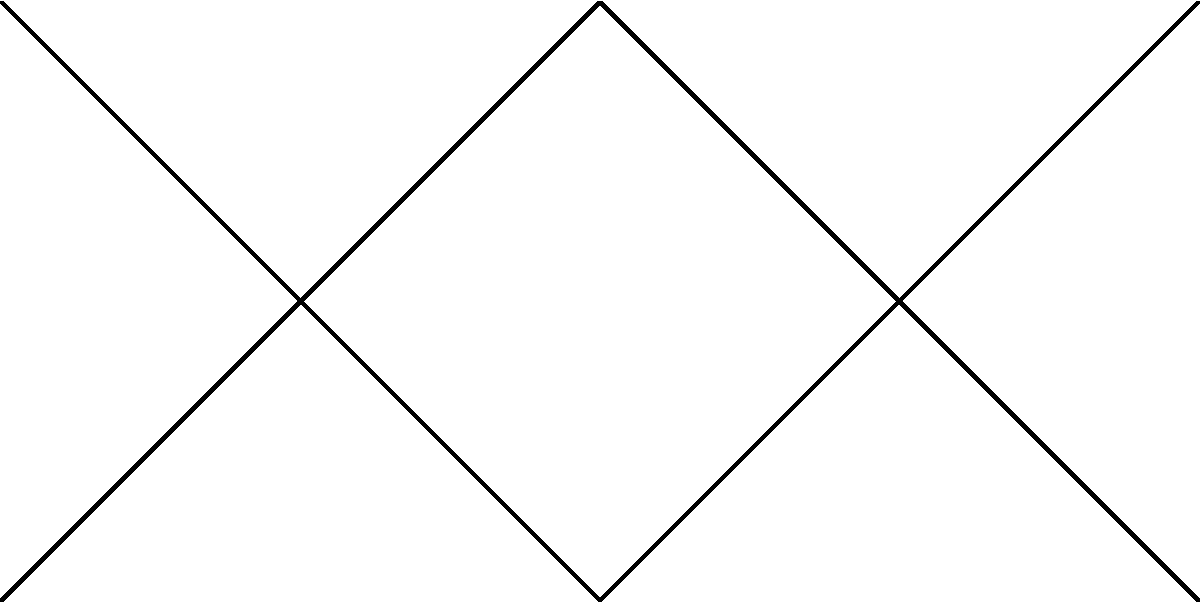As an air traffic controller managing frequency assignments, you need to color a map of airspace sectors to avoid interference. Given the diagram representing adjacent airspace sectors, what is the minimum number of frequencies (colors) needed to ensure no adjacent sectors have the same frequency? To solve this problem, we'll use the concept of graph coloring:

1. Each vertex (S1, S2, etc.) represents an airspace sector.
2. Edges between vertices indicate adjacent sectors.
3. We need to assign colors (frequencies) so that no adjacent vertices have the same color.

Let's color the graph step by step:

1. Start with S1 (color 1).
2. S2 is adjacent to S1, so it needs a different color (color 2).
3. S3 is adjacent to S2, so it needs a new color (color 3).
4. S4 is adjacent to S1, S2, and S3, so it needs a new color (color 4).
5. S5 is adjacent to S1 and S2, but can use color 3.
6. S6 is adjacent to S2, S3, and S5, but can use color 4.
7. S7 is adjacent to S1 and S4, but can use color 2.
8. S8 is adjacent to S3, S4, and S7, but can use color 1.

We used a total of 4 colors, and it's impossible to color the graph with fewer colors due to the subgraph formed by S1, S2, S3, and S4, which forms a complete graph of 4 vertices (K4).

This problem is related to the Four Color Theorem, which states that any planar graph can be colored with at most four colors. Our graph, representing airspace sectors, is planar, so four colors are sufficient.
Answer: 4 frequencies 